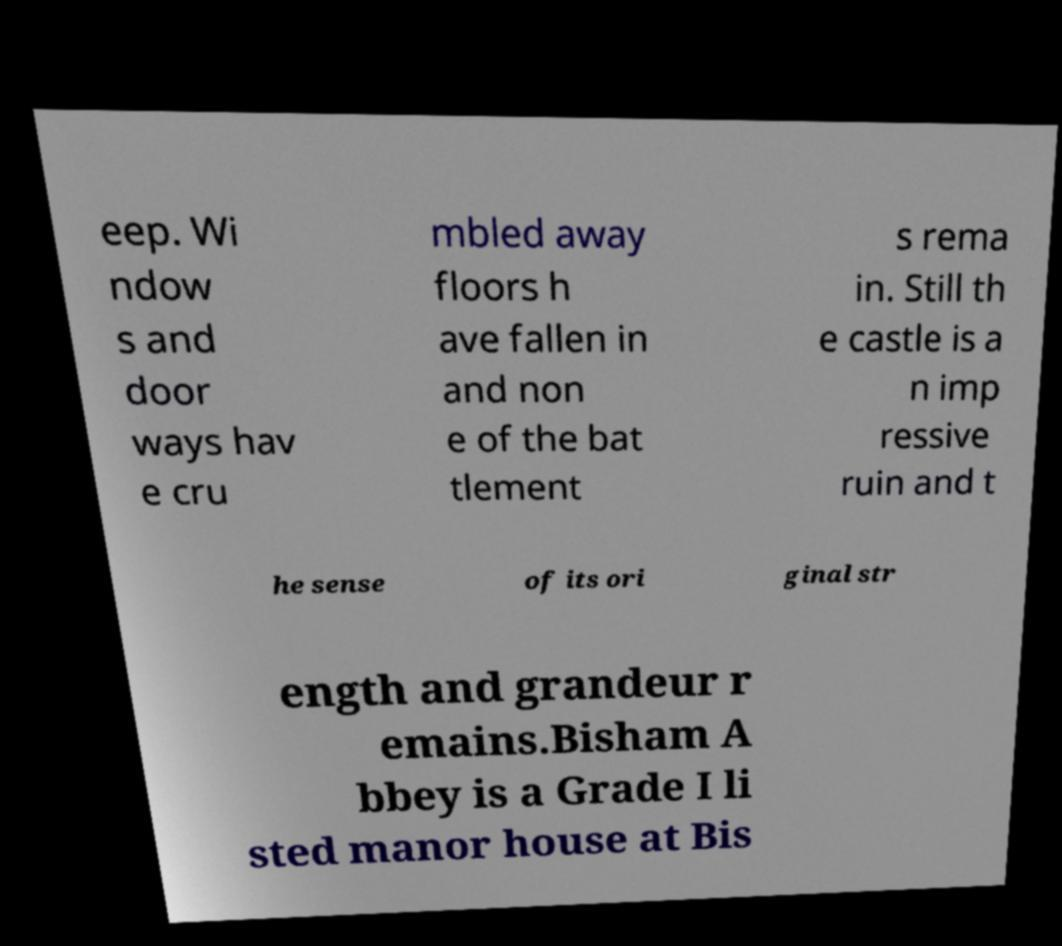Please read and relay the text visible in this image. What does it say? eep. Wi ndow s and door ways hav e cru mbled away floors h ave fallen in and non e of the bat tlement s rema in. Still th e castle is a n imp ressive ruin and t he sense of its ori ginal str ength and grandeur r emains.Bisham A bbey is a Grade I li sted manor house at Bis 